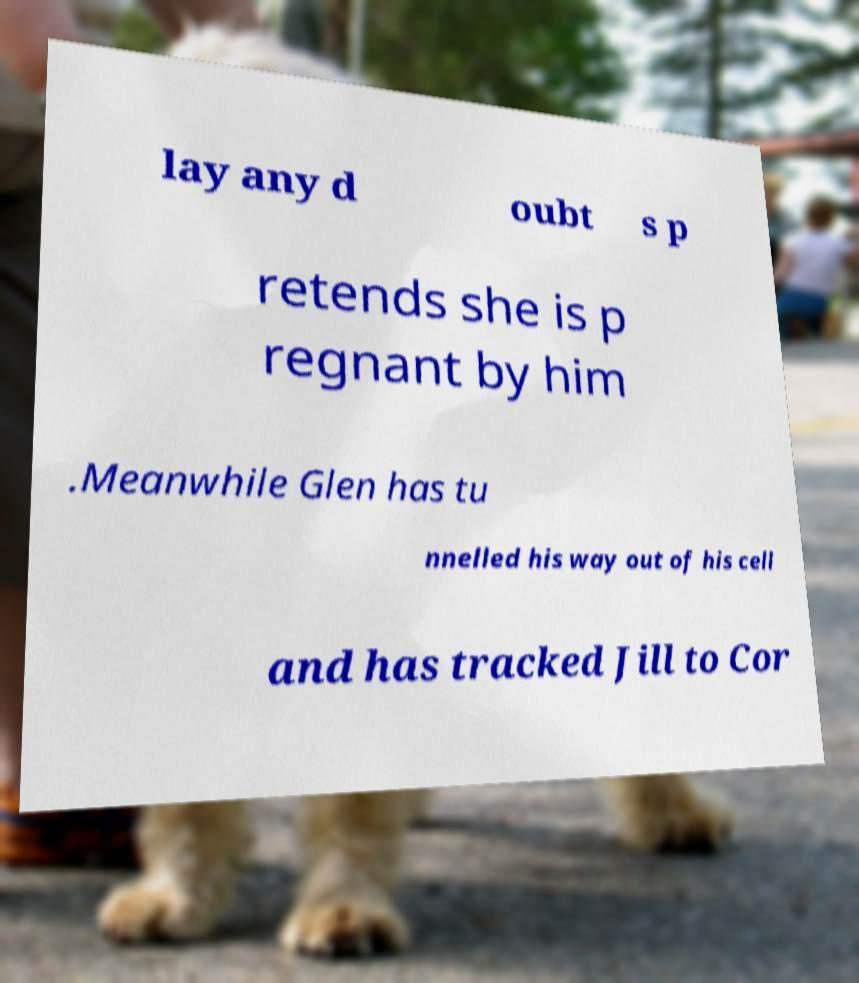For documentation purposes, I need the text within this image transcribed. Could you provide that? lay any d oubt s p retends she is p regnant by him .Meanwhile Glen has tu nnelled his way out of his cell and has tracked Jill to Cor 